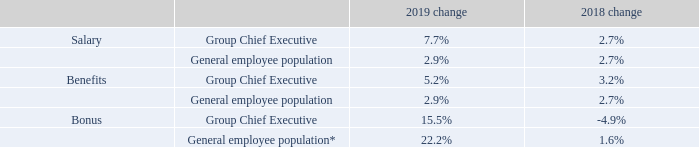1.10 Percentage change in remuneration of the Group Chief Executive
The following table provides a summary of the 2019 increase in base salary, benefits and bonus for the Group Chief Executive compared to the average increase for the general UK employee population across the Group in the same period.
* 2018 percentage restated to include all UK bonuses for the general UK employee population across the Group.
Why was there an adjustment under Bonus for general employee population? 2018 percentage restated to include all uk bonuses for the general uk employee population across the group. What was the 2019 increase in base salary, benefits and bonus for the Group Chief Executive compared against? Compared to the average increase for the general uk employee population across the group in the same period. What are the components of remuneration reflected in the table? Salary, benefits, bonus. In which year was the change in salary for the general employee population larger? 2.9%>2.7%
Answer: 2019. What was the absolute change in the change in salary for the group chief executive in 2019 from 2018? 
Answer scale should be: percent. 7.7%-2.7%
Answer: 5. What was the percentage change in the change in salary for the group chief executive in 2019 from 2018? 
Answer scale should be: percent. (7.7-2.7)/2.7
Answer: 185.19. 